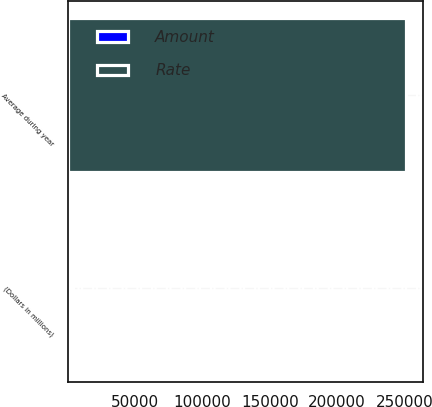<chart> <loc_0><loc_0><loc_500><loc_500><stacked_bar_chart><ecel><fcel>(Dollars in millions)<fcel>Average during year<nl><fcel>Rate<fcel>2018<fcel>251328<nl><fcel>Amount<fcel>2018<fcel>1.26<nl></chart> 